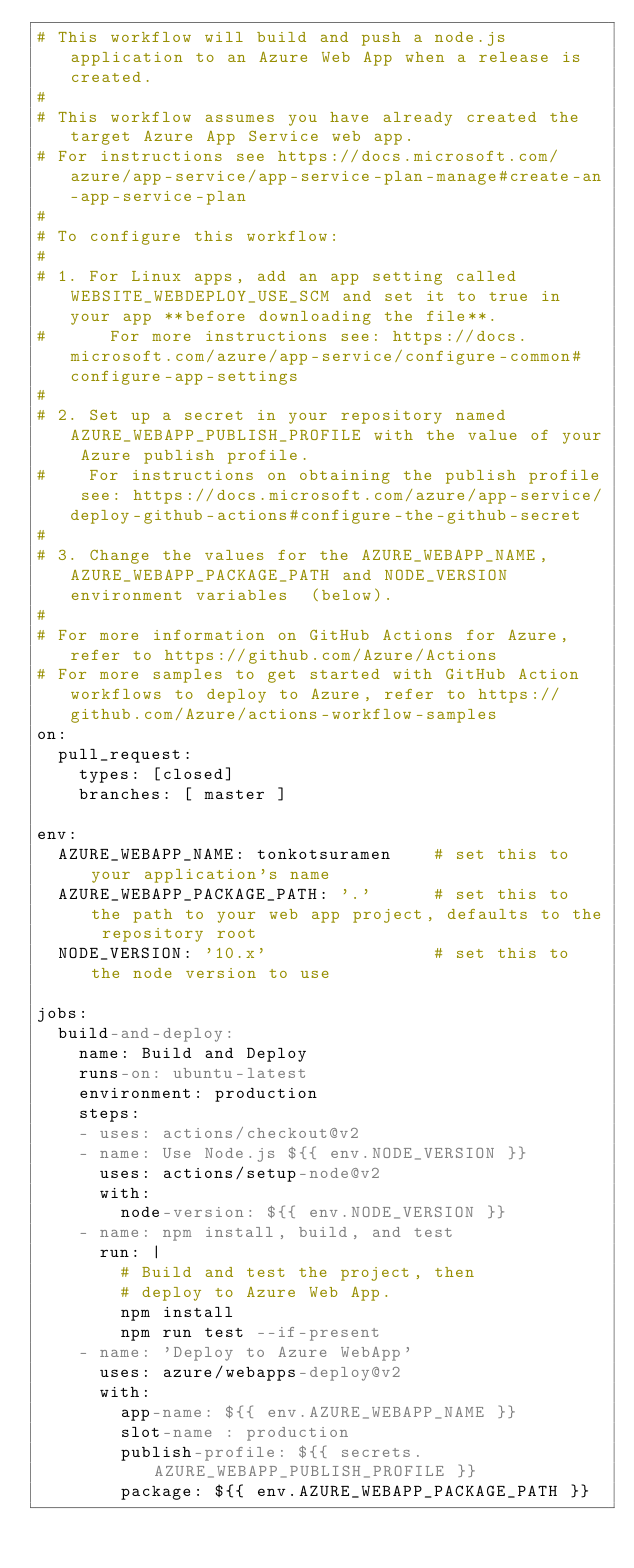<code> <loc_0><loc_0><loc_500><loc_500><_YAML_># This workflow will build and push a node.js application to an Azure Web App when a release is created.
#
# This workflow assumes you have already created the target Azure App Service web app.
# For instructions see https://docs.microsoft.com/azure/app-service/app-service-plan-manage#create-an-app-service-plan
#
# To configure this workflow:
#
# 1. For Linux apps, add an app setting called WEBSITE_WEBDEPLOY_USE_SCM and set it to true in your app **before downloading the file**.
#      For more instructions see: https://docs.microsoft.com/azure/app-service/configure-common#configure-app-settings
#
# 2. Set up a secret in your repository named AZURE_WEBAPP_PUBLISH_PROFILE with the value of your Azure publish profile.
#    For instructions on obtaining the publish profile see: https://docs.microsoft.com/azure/app-service/deploy-github-actions#configure-the-github-secret
#
# 3. Change the values for the AZURE_WEBAPP_NAME, AZURE_WEBAPP_PACKAGE_PATH and NODE_VERSION environment variables  (below).
#
# For more information on GitHub Actions for Azure, refer to https://github.com/Azure/Actions
# For more samples to get started with GitHub Action workflows to deploy to Azure, refer to https://github.com/Azure/actions-workflow-samples
on:
  pull_request:
    types: [closed]
    branches: [ master ]

env:
  AZURE_WEBAPP_NAME: tonkotsuramen    # set this to your application's name
  AZURE_WEBAPP_PACKAGE_PATH: '.'      # set this to the path to your web app project, defaults to the repository root
  NODE_VERSION: '10.x'                # set this to the node version to use

jobs:
  build-and-deploy:
    name: Build and Deploy
    runs-on: ubuntu-latest
    environment: production
    steps:
    - uses: actions/checkout@v2
    - name: Use Node.js ${{ env.NODE_VERSION }}
      uses: actions/setup-node@v2
      with:
        node-version: ${{ env.NODE_VERSION }}
    - name: npm install, build, and test
      run: |
        # Build and test the project, then
        # deploy to Azure Web App.
        npm install
        npm run test --if-present
    - name: 'Deploy to Azure WebApp'
      uses: azure/webapps-deploy@v2
      with:
        app-name: ${{ env.AZURE_WEBAPP_NAME }}
        slot-name : production
        publish-profile: ${{ secrets.AZURE_WEBAPP_PUBLISH_PROFILE }}
        package: ${{ env.AZURE_WEBAPP_PACKAGE_PATH }}
</code> 